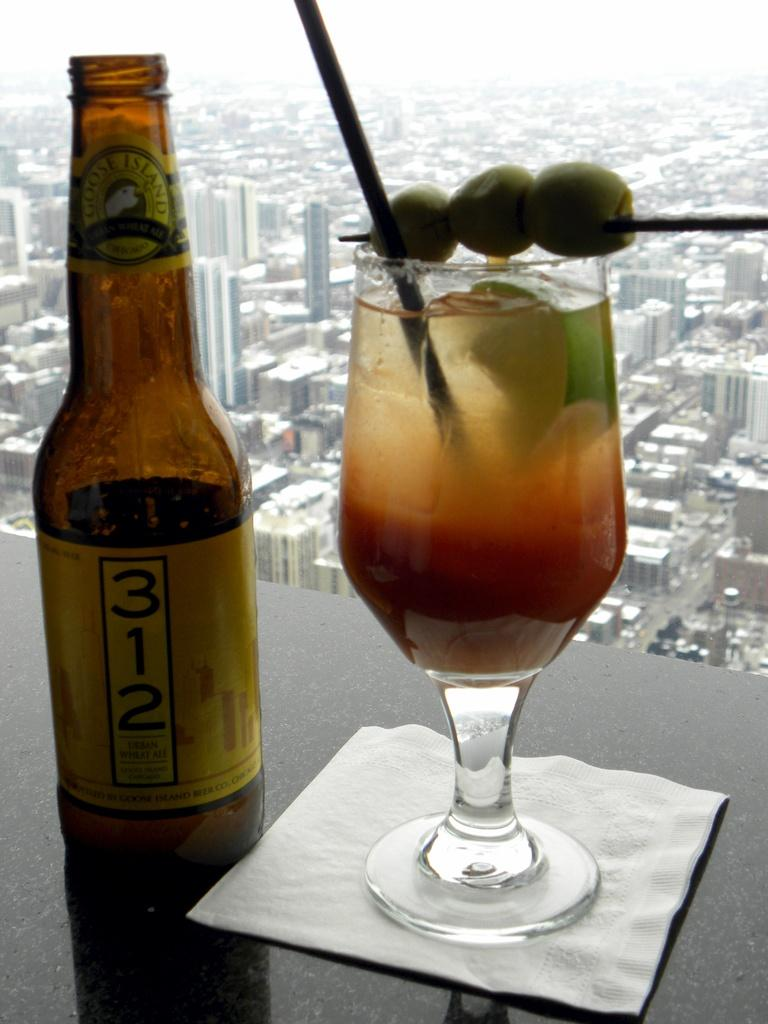Provide a one-sentence caption for the provided image. A bottle of Goose Island 312 label sits on table next to a mixed drink on a napkin by a window overlooking a city. 